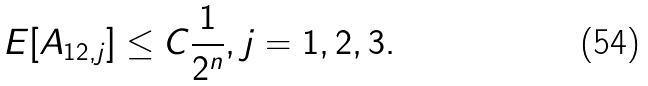<formula> <loc_0><loc_0><loc_500><loc_500>E [ A _ { 1 2 , j } ] \leq C \frac { 1 } { 2 ^ { n } } , j = 1 , 2 , 3 .</formula> 